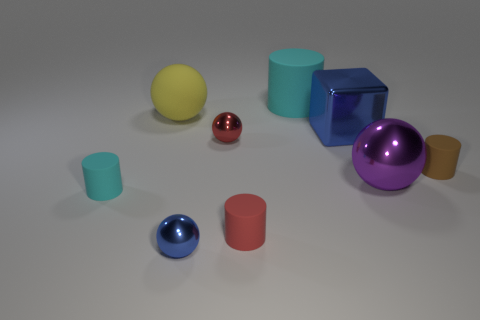Are there any small cyan matte cylinders behind the yellow object?
Ensure brevity in your answer.  No. There is a small matte thing that is the same color as the large rubber cylinder; what is its shape?
Make the answer very short. Cylinder. What number of things are either tiny objects behind the red cylinder or big blue metal objects?
Provide a succinct answer. 4. There is a red thing that is the same material as the small brown object; what size is it?
Provide a succinct answer. Small. Does the purple shiny object have the same size as the matte cylinder that is left of the yellow rubber ball?
Provide a succinct answer. No. There is a tiny rubber cylinder that is both behind the red rubber object and to the right of the big yellow sphere; what color is it?
Keep it short and to the point. Brown. How many objects are cyan rubber objects right of the matte ball or objects that are on the left side of the brown matte thing?
Make the answer very short. 8. The small sphere that is behind the cyan object that is in front of the tiny metallic object that is behind the big shiny ball is what color?
Your answer should be compact. Red. Are there any large blue metal things of the same shape as the large yellow thing?
Make the answer very short. No. How many tiny brown shiny spheres are there?
Your answer should be compact. 0. 